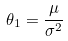Convert formula to latex. <formula><loc_0><loc_0><loc_500><loc_500>\theta _ { 1 } = \frac { \mu } { \sigma ^ { 2 } }</formula> 